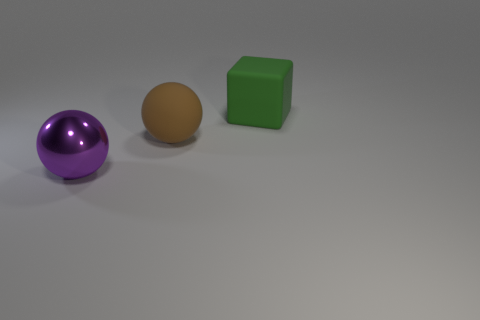Add 1 small brown rubber cylinders. How many objects exist? 4 Subtract all balls. How many objects are left? 1 Subtract 0 yellow cylinders. How many objects are left? 3 Subtract all tiny purple matte blocks. Subtract all green cubes. How many objects are left? 2 Add 3 big green things. How many big green things are left? 4 Add 3 big things. How many big things exist? 6 